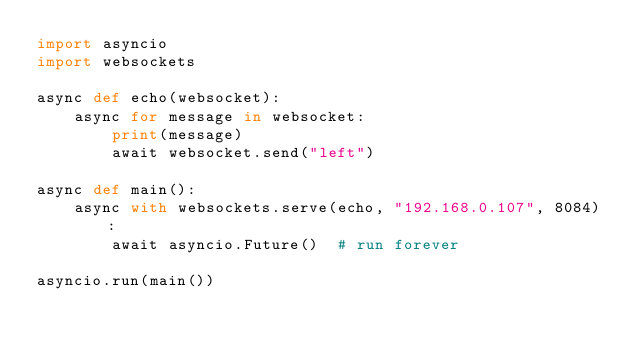Convert code to text. <code><loc_0><loc_0><loc_500><loc_500><_Python_>import asyncio
import websockets

async def echo(websocket):
    async for message in websocket:
        print(message)
        await websocket.send("left")

async def main():
    async with websockets.serve(echo, "192.168.0.107", 8084):
        await asyncio.Future()  # run forever

asyncio.run(main())</code> 